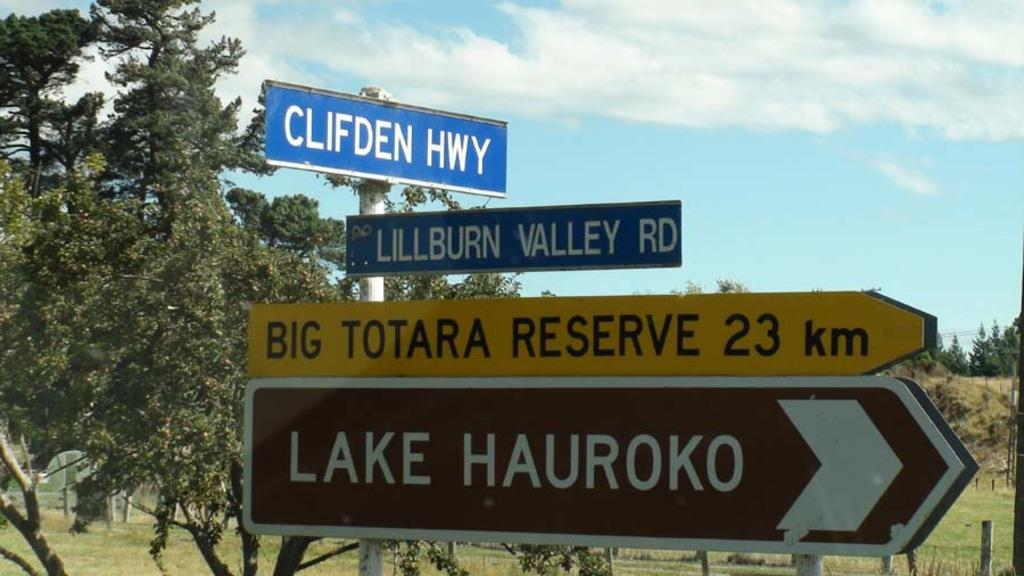<image>
Render a clear and concise summary of the photo. A grouping of signs pointing in the directions of Lake Hauroko and Clifden Highway. 